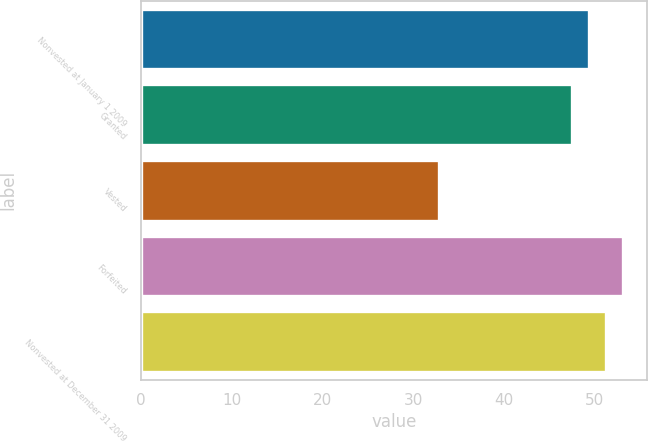Convert chart. <chart><loc_0><loc_0><loc_500><loc_500><bar_chart><fcel>Nonvested at January 1 2009<fcel>Granted<fcel>Vested<fcel>Forfeited<fcel>Nonvested at December 31 2009<nl><fcel>49.39<fcel>47.43<fcel>32.84<fcel>53.13<fcel>51.26<nl></chart> 